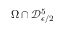<formula> <loc_0><loc_0><loc_500><loc_500>\Omega \cap \mathcal { D } _ { \epsilon / 2 } ^ { 5 }</formula> 